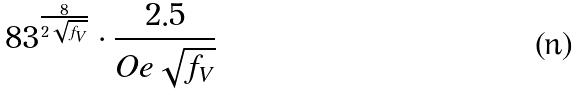Convert formula to latex. <formula><loc_0><loc_0><loc_500><loc_500>8 3 ^ { \frac { 8 } { 2 \sqrt { f _ { V } } } } \cdot \frac { 2 . 5 } { O e \sqrt { f _ { V } } }</formula> 